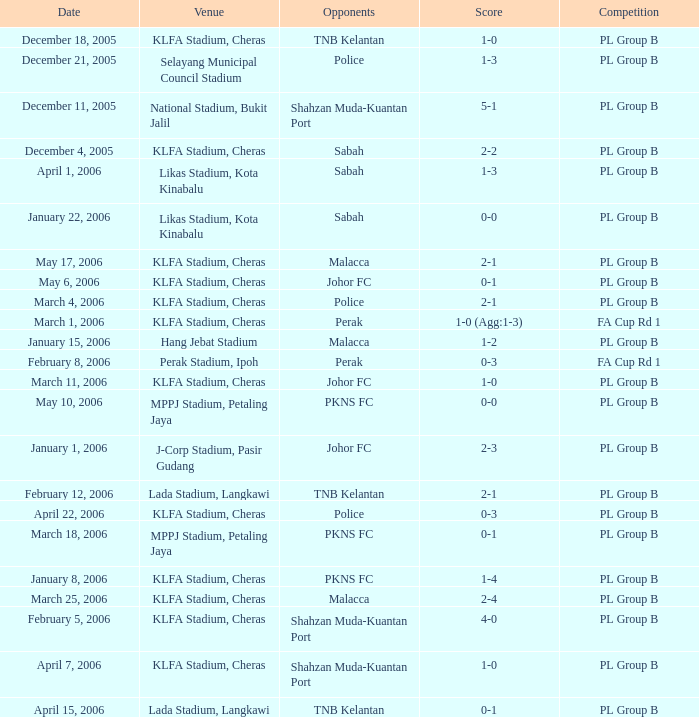Can you give me this table as a dict? {'header': ['Date', 'Venue', 'Opponents', 'Score', 'Competition'], 'rows': [['December 18, 2005', 'KLFA Stadium, Cheras', 'TNB Kelantan', '1-0', 'PL Group B'], ['December 21, 2005', 'Selayang Municipal Council Stadium', 'Police', '1-3', 'PL Group B'], ['December 11, 2005', 'National Stadium, Bukit Jalil', 'Shahzan Muda-Kuantan Port', '5-1', 'PL Group B'], ['December 4, 2005', 'KLFA Stadium, Cheras', 'Sabah', '2-2', 'PL Group B'], ['April 1, 2006', 'Likas Stadium, Kota Kinabalu', 'Sabah', '1-3', 'PL Group B'], ['January 22, 2006', 'Likas Stadium, Kota Kinabalu', 'Sabah', '0-0', 'PL Group B'], ['May 17, 2006', 'KLFA Stadium, Cheras', 'Malacca', '2-1', 'PL Group B'], ['May 6, 2006', 'KLFA Stadium, Cheras', 'Johor FC', '0-1', 'PL Group B'], ['March 4, 2006', 'KLFA Stadium, Cheras', 'Police', '2-1', 'PL Group B'], ['March 1, 2006', 'KLFA Stadium, Cheras', 'Perak', '1-0 (Agg:1-3)', 'FA Cup Rd 1'], ['January 15, 2006', 'Hang Jebat Stadium', 'Malacca', '1-2', 'PL Group B'], ['February 8, 2006', 'Perak Stadium, Ipoh', 'Perak', '0-3', 'FA Cup Rd 1'], ['March 11, 2006', 'KLFA Stadium, Cheras', 'Johor FC', '1-0', 'PL Group B'], ['May 10, 2006', 'MPPJ Stadium, Petaling Jaya', 'PKNS FC', '0-0', 'PL Group B'], ['January 1, 2006', 'J-Corp Stadium, Pasir Gudang', 'Johor FC', '2-3', 'PL Group B'], ['February 12, 2006', 'Lada Stadium, Langkawi', 'TNB Kelantan', '2-1', 'PL Group B'], ['April 22, 2006', 'KLFA Stadium, Cheras', 'Police', '0-3', 'PL Group B'], ['March 18, 2006', 'MPPJ Stadium, Petaling Jaya', 'PKNS FC', '0-1', 'PL Group B'], ['January 8, 2006', 'KLFA Stadium, Cheras', 'PKNS FC', '1-4', 'PL Group B'], ['March 25, 2006', 'KLFA Stadium, Cheras', 'Malacca', '2-4', 'PL Group B'], ['February 5, 2006', 'KLFA Stadium, Cheras', 'Shahzan Muda-Kuantan Port', '4-0', 'PL Group B'], ['April 7, 2006', 'KLFA Stadium, Cheras', 'Shahzan Muda-Kuantan Port', '1-0', 'PL Group B'], ['April 15, 2006', 'Lada Stadium, Langkawi', 'TNB Kelantan', '0-1', 'PL Group B']]} Who competed on may 6, 2006? Johor FC. 